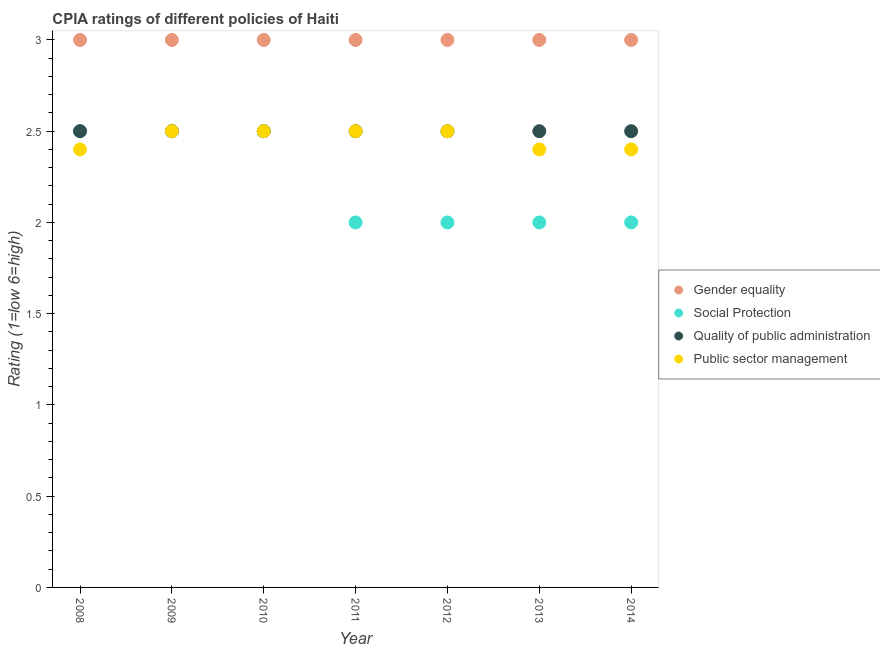What is the difference between the cpia rating of social protection in 2012 and the cpia rating of public sector management in 2008?
Your answer should be compact. -0.4. What is the ratio of the cpia rating of public sector management in 2011 to that in 2013?
Ensure brevity in your answer.  1.04. What is the difference between the highest and the second highest cpia rating of public sector management?
Your answer should be very brief. 0. In how many years, is the cpia rating of gender equality greater than the average cpia rating of gender equality taken over all years?
Provide a succinct answer. 0. Is the sum of the cpia rating of public sector management in 2009 and 2014 greater than the maximum cpia rating of social protection across all years?
Offer a very short reply. Yes. Is it the case that in every year, the sum of the cpia rating of quality of public administration and cpia rating of gender equality is greater than the sum of cpia rating of public sector management and cpia rating of social protection?
Your answer should be compact. Yes. Is it the case that in every year, the sum of the cpia rating of gender equality and cpia rating of social protection is greater than the cpia rating of quality of public administration?
Your response must be concise. Yes. Does the cpia rating of social protection monotonically increase over the years?
Give a very brief answer. No. Is the cpia rating of quality of public administration strictly less than the cpia rating of gender equality over the years?
Provide a succinct answer. Yes. How many years are there in the graph?
Your answer should be compact. 7. Does the graph contain any zero values?
Offer a terse response. No. Does the graph contain grids?
Ensure brevity in your answer.  No. How many legend labels are there?
Provide a short and direct response. 4. What is the title of the graph?
Provide a short and direct response. CPIA ratings of different policies of Haiti. What is the label or title of the Y-axis?
Provide a short and direct response. Rating (1=low 6=high). What is the Rating (1=low 6=high) in Gender equality in 2008?
Offer a very short reply. 3. What is the Rating (1=low 6=high) in Social Protection in 2008?
Offer a terse response. 2.5. What is the Rating (1=low 6=high) in Quality of public administration in 2008?
Ensure brevity in your answer.  2.5. What is the Rating (1=low 6=high) in Public sector management in 2008?
Your answer should be very brief. 2.4. What is the Rating (1=low 6=high) of Gender equality in 2009?
Keep it short and to the point. 3. What is the Rating (1=low 6=high) in Quality of public administration in 2009?
Offer a terse response. 2.5. What is the Rating (1=low 6=high) in Public sector management in 2009?
Offer a very short reply. 2.5. What is the Rating (1=low 6=high) in Quality of public administration in 2011?
Your answer should be very brief. 2.5. What is the Rating (1=low 6=high) of Public sector management in 2011?
Provide a succinct answer. 2.5. What is the Rating (1=low 6=high) of Quality of public administration in 2013?
Your answer should be compact. 2.5. What is the Rating (1=low 6=high) of Public sector management in 2014?
Provide a short and direct response. 2.4. Across all years, what is the maximum Rating (1=low 6=high) of Social Protection?
Ensure brevity in your answer.  2.5. Across all years, what is the maximum Rating (1=low 6=high) in Quality of public administration?
Keep it short and to the point. 2.5. Across all years, what is the minimum Rating (1=low 6=high) in Social Protection?
Keep it short and to the point. 2. Across all years, what is the minimum Rating (1=low 6=high) of Public sector management?
Your answer should be very brief. 2.4. What is the total Rating (1=low 6=high) in Gender equality in the graph?
Offer a terse response. 21. What is the total Rating (1=low 6=high) in Social Protection in the graph?
Make the answer very short. 15.5. What is the total Rating (1=low 6=high) in Public sector management in the graph?
Offer a very short reply. 17.2. What is the difference between the Rating (1=low 6=high) of Gender equality in 2008 and that in 2009?
Give a very brief answer. 0. What is the difference between the Rating (1=low 6=high) of Gender equality in 2008 and that in 2010?
Offer a terse response. 0. What is the difference between the Rating (1=low 6=high) of Public sector management in 2008 and that in 2010?
Give a very brief answer. -0.1. What is the difference between the Rating (1=low 6=high) of Quality of public administration in 2008 and that in 2011?
Offer a terse response. 0. What is the difference between the Rating (1=low 6=high) of Gender equality in 2008 and that in 2012?
Provide a short and direct response. 0. What is the difference between the Rating (1=low 6=high) in Social Protection in 2008 and that in 2012?
Provide a succinct answer. 0.5. What is the difference between the Rating (1=low 6=high) of Social Protection in 2008 and that in 2013?
Offer a very short reply. 0.5. What is the difference between the Rating (1=low 6=high) of Quality of public administration in 2008 and that in 2013?
Your response must be concise. 0. What is the difference between the Rating (1=low 6=high) of Public sector management in 2008 and that in 2013?
Your answer should be compact. 0. What is the difference between the Rating (1=low 6=high) of Quality of public administration in 2008 and that in 2014?
Offer a very short reply. 0. What is the difference between the Rating (1=low 6=high) of Social Protection in 2009 and that in 2010?
Your answer should be compact. 0. What is the difference between the Rating (1=low 6=high) in Quality of public administration in 2009 and that in 2010?
Your answer should be compact. 0. What is the difference between the Rating (1=low 6=high) of Gender equality in 2009 and that in 2012?
Your answer should be compact. 0. What is the difference between the Rating (1=low 6=high) in Social Protection in 2009 and that in 2012?
Your answer should be compact. 0.5. What is the difference between the Rating (1=low 6=high) in Quality of public administration in 2009 and that in 2012?
Give a very brief answer. 0. What is the difference between the Rating (1=low 6=high) of Public sector management in 2009 and that in 2012?
Your response must be concise. 0. What is the difference between the Rating (1=low 6=high) of Gender equality in 2009 and that in 2013?
Provide a succinct answer. 0. What is the difference between the Rating (1=low 6=high) in Social Protection in 2009 and that in 2013?
Keep it short and to the point. 0.5. What is the difference between the Rating (1=low 6=high) of Public sector management in 2009 and that in 2013?
Make the answer very short. 0.1. What is the difference between the Rating (1=low 6=high) in Gender equality in 2009 and that in 2014?
Make the answer very short. 0. What is the difference between the Rating (1=low 6=high) in Social Protection in 2009 and that in 2014?
Offer a terse response. 0.5. What is the difference between the Rating (1=low 6=high) in Quality of public administration in 2009 and that in 2014?
Provide a short and direct response. 0. What is the difference between the Rating (1=low 6=high) of Public sector management in 2009 and that in 2014?
Your answer should be very brief. 0.1. What is the difference between the Rating (1=low 6=high) of Social Protection in 2010 and that in 2011?
Ensure brevity in your answer.  0.5. What is the difference between the Rating (1=low 6=high) of Quality of public administration in 2010 and that in 2011?
Your response must be concise. 0. What is the difference between the Rating (1=low 6=high) of Quality of public administration in 2010 and that in 2012?
Make the answer very short. 0. What is the difference between the Rating (1=low 6=high) in Public sector management in 2010 and that in 2012?
Give a very brief answer. 0. What is the difference between the Rating (1=low 6=high) in Gender equality in 2010 and that in 2013?
Provide a succinct answer. 0. What is the difference between the Rating (1=low 6=high) of Social Protection in 2010 and that in 2013?
Offer a very short reply. 0.5. What is the difference between the Rating (1=low 6=high) in Public sector management in 2010 and that in 2014?
Offer a terse response. 0.1. What is the difference between the Rating (1=low 6=high) of Social Protection in 2011 and that in 2012?
Provide a succinct answer. 0. What is the difference between the Rating (1=low 6=high) in Quality of public administration in 2011 and that in 2012?
Your answer should be compact. 0. What is the difference between the Rating (1=low 6=high) in Public sector management in 2011 and that in 2012?
Provide a succinct answer. 0. What is the difference between the Rating (1=low 6=high) in Social Protection in 2011 and that in 2013?
Provide a short and direct response. 0. What is the difference between the Rating (1=low 6=high) of Quality of public administration in 2011 and that in 2013?
Provide a short and direct response. 0. What is the difference between the Rating (1=low 6=high) of Public sector management in 2011 and that in 2013?
Make the answer very short. 0.1. What is the difference between the Rating (1=low 6=high) of Gender equality in 2011 and that in 2014?
Ensure brevity in your answer.  0. What is the difference between the Rating (1=low 6=high) in Social Protection in 2011 and that in 2014?
Your answer should be compact. 0. What is the difference between the Rating (1=low 6=high) of Gender equality in 2012 and that in 2013?
Provide a short and direct response. 0. What is the difference between the Rating (1=low 6=high) of Social Protection in 2012 and that in 2013?
Offer a very short reply. 0. What is the difference between the Rating (1=low 6=high) of Quality of public administration in 2012 and that in 2013?
Keep it short and to the point. 0. What is the difference between the Rating (1=low 6=high) in Public sector management in 2012 and that in 2013?
Give a very brief answer. 0.1. What is the difference between the Rating (1=low 6=high) in Gender equality in 2012 and that in 2014?
Provide a short and direct response. 0. What is the difference between the Rating (1=low 6=high) of Public sector management in 2012 and that in 2014?
Offer a very short reply. 0.1. What is the difference between the Rating (1=low 6=high) in Gender equality in 2013 and that in 2014?
Provide a succinct answer. 0. What is the difference between the Rating (1=low 6=high) of Social Protection in 2013 and that in 2014?
Provide a succinct answer. 0. What is the difference between the Rating (1=low 6=high) in Quality of public administration in 2013 and that in 2014?
Ensure brevity in your answer.  0. What is the difference between the Rating (1=low 6=high) of Public sector management in 2013 and that in 2014?
Your answer should be compact. 0. What is the difference between the Rating (1=low 6=high) in Gender equality in 2008 and the Rating (1=low 6=high) in Social Protection in 2009?
Ensure brevity in your answer.  0.5. What is the difference between the Rating (1=low 6=high) of Gender equality in 2008 and the Rating (1=low 6=high) of Quality of public administration in 2009?
Make the answer very short. 0.5. What is the difference between the Rating (1=low 6=high) in Gender equality in 2008 and the Rating (1=low 6=high) in Public sector management in 2009?
Offer a terse response. 0.5. What is the difference between the Rating (1=low 6=high) in Social Protection in 2008 and the Rating (1=low 6=high) in Public sector management in 2009?
Your response must be concise. 0. What is the difference between the Rating (1=low 6=high) in Gender equality in 2008 and the Rating (1=low 6=high) in Social Protection in 2010?
Keep it short and to the point. 0.5. What is the difference between the Rating (1=low 6=high) of Gender equality in 2008 and the Rating (1=low 6=high) of Public sector management in 2010?
Provide a short and direct response. 0.5. What is the difference between the Rating (1=low 6=high) in Social Protection in 2008 and the Rating (1=low 6=high) in Public sector management in 2010?
Your answer should be very brief. 0. What is the difference between the Rating (1=low 6=high) of Quality of public administration in 2008 and the Rating (1=low 6=high) of Public sector management in 2010?
Your answer should be compact. 0. What is the difference between the Rating (1=low 6=high) of Gender equality in 2008 and the Rating (1=low 6=high) of Social Protection in 2011?
Offer a very short reply. 1. What is the difference between the Rating (1=low 6=high) in Gender equality in 2008 and the Rating (1=low 6=high) in Quality of public administration in 2011?
Provide a short and direct response. 0.5. What is the difference between the Rating (1=low 6=high) in Gender equality in 2008 and the Rating (1=low 6=high) in Public sector management in 2011?
Provide a short and direct response. 0.5. What is the difference between the Rating (1=low 6=high) of Social Protection in 2008 and the Rating (1=low 6=high) of Public sector management in 2011?
Give a very brief answer. 0. What is the difference between the Rating (1=low 6=high) in Quality of public administration in 2008 and the Rating (1=low 6=high) in Public sector management in 2011?
Provide a short and direct response. 0. What is the difference between the Rating (1=low 6=high) of Gender equality in 2008 and the Rating (1=low 6=high) of Social Protection in 2012?
Make the answer very short. 1. What is the difference between the Rating (1=low 6=high) of Gender equality in 2008 and the Rating (1=low 6=high) of Quality of public administration in 2012?
Ensure brevity in your answer.  0.5. What is the difference between the Rating (1=low 6=high) of Gender equality in 2008 and the Rating (1=low 6=high) of Social Protection in 2013?
Keep it short and to the point. 1. What is the difference between the Rating (1=low 6=high) in Gender equality in 2008 and the Rating (1=low 6=high) in Quality of public administration in 2013?
Give a very brief answer. 0.5. What is the difference between the Rating (1=low 6=high) of Gender equality in 2008 and the Rating (1=low 6=high) of Public sector management in 2013?
Ensure brevity in your answer.  0.6. What is the difference between the Rating (1=low 6=high) of Quality of public administration in 2008 and the Rating (1=low 6=high) of Public sector management in 2013?
Offer a terse response. 0.1. What is the difference between the Rating (1=low 6=high) in Gender equality in 2008 and the Rating (1=low 6=high) in Social Protection in 2014?
Make the answer very short. 1. What is the difference between the Rating (1=low 6=high) of Gender equality in 2008 and the Rating (1=low 6=high) of Public sector management in 2014?
Ensure brevity in your answer.  0.6. What is the difference between the Rating (1=low 6=high) in Social Protection in 2008 and the Rating (1=low 6=high) in Quality of public administration in 2014?
Your answer should be very brief. 0. What is the difference between the Rating (1=low 6=high) of Social Protection in 2008 and the Rating (1=low 6=high) of Public sector management in 2014?
Your response must be concise. 0.1. What is the difference between the Rating (1=low 6=high) in Quality of public administration in 2008 and the Rating (1=low 6=high) in Public sector management in 2014?
Give a very brief answer. 0.1. What is the difference between the Rating (1=low 6=high) of Gender equality in 2009 and the Rating (1=low 6=high) of Social Protection in 2010?
Ensure brevity in your answer.  0.5. What is the difference between the Rating (1=low 6=high) in Gender equality in 2009 and the Rating (1=low 6=high) in Quality of public administration in 2010?
Offer a very short reply. 0.5. What is the difference between the Rating (1=low 6=high) in Social Protection in 2009 and the Rating (1=low 6=high) in Public sector management in 2010?
Your answer should be compact. 0. What is the difference between the Rating (1=low 6=high) in Gender equality in 2009 and the Rating (1=low 6=high) in Social Protection in 2011?
Your response must be concise. 1. What is the difference between the Rating (1=low 6=high) of Gender equality in 2009 and the Rating (1=low 6=high) of Quality of public administration in 2011?
Provide a succinct answer. 0.5. What is the difference between the Rating (1=low 6=high) in Gender equality in 2009 and the Rating (1=low 6=high) in Public sector management in 2011?
Make the answer very short. 0.5. What is the difference between the Rating (1=low 6=high) in Quality of public administration in 2009 and the Rating (1=low 6=high) in Public sector management in 2011?
Your answer should be compact. 0. What is the difference between the Rating (1=low 6=high) of Gender equality in 2009 and the Rating (1=low 6=high) of Public sector management in 2012?
Your response must be concise. 0.5. What is the difference between the Rating (1=low 6=high) in Social Protection in 2009 and the Rating (1=low 6=high) in Public sector management in 2012?
Your answer should be very brief. 0. What is the difference between the Rating (1=low 6=high) in Gender equality in 2009 and the Rating (1=low 6=high) in Social Protection in 2013?
Make the answer very short. 1. What is the difference between the Rating (1=low 6=high) of Gender equality in 2009 and the Rating (1=low 6=high) of Quality of public administration in 2013?
Your answer should be compact. 0.5. What is the difference between the Rating (1=low 6=high) in Social Protection in 2009 and the Rating (1=low 6=high) in Quality of public administration in 2013?
Keep it short and to the point. 0. What is the difference between the Rating (1=low 6=high) of Quality of public administration in 2009 and the Rating (1=low 6=high) of Public sector management in 2013?
Ensure brevity in your answer.  0.1. What is the difference between the Rating (1=low 6=high) of Gender equality in 2009 and the Rating (1=low 6=high) of Quality of public administration in 2014?
Your response must be concise. 0.5. What is the difference between the Rating (1=low 6=high) in Social Protection in 2009 and the Rating (1=low 6=high) in Quality of public administration in 2014?
Your answer should be very brief. 0. What is the difference between the Rating (1=low 6=high) in Social Protection in 2009 and the Rating (1=low 6=high) in Public sector management in 2014?
Provide a short and direct response. 0.1. What is the difference between the Rating (1=low 6=high) in Quality of public administration in 2009 and the Rating (1=low 6=high) in Public sector management in 2014?
Your answer should be compact. 0.1. What is the difference between the Rating (1=low 6=high) of Social Protection in 2010 and the Rating (1=low 6=high) of Quality of public administration in 2011?
Provide a short and direct response. 0. What is the difference between the Rating (1=low 6=high) in Social Protection in 2010 and the Rating (1=low 6=high) in Public sector management in 2011?
Make the answer very short. 0. What is the difference between the Rating (1=low 6=high) of Gender equality in 2010 and the Rating (1=low 6=high) of Social Protection in 2012?
Keep it short and to the point. 1. What is the difference between the Rating (1=low 6=high) in Social Protection in 2010 and the Rating (1=low 6=high) in Quality of public administration in 2012?
Ensure brevity in your answer.  0. What is the difference between the Rating (1=low 6=high) of Social Protection in 2010 and the Rating (1=low 6=high) of Public sector management in 2012?
Your answer should be very brief. 0. What is the difference between the Rating (1=low 6=high) in Gender equality in 2010 and the Rating (1=low 6=high) in Public sector management in 2013?
Provide a succinct answer. 0.6. What is the difference between the Rating (1=low 6=high) in Quality of public administration in 2010 and the Rating (1=low 6=high) in Public sector management in 2013?
Your response must be concise. 0.1. What is the difference between the Rating (1=low 6=high) of Gender equality in 2010 and the Rating (1=low 6=high) of Public sector management in 2014?
Give a very brief answer. 0.6. What is the difference between the Rating (1=low 6=high) in Social Protection in 2010 and the Rating (1=low 6=high) in Quality of public administration in 2014?
Offer a very short reply. 0. What is the difference between the Rating (1=low 6=high) of Quality of public administration in 2010 and the Rating (1=low 6=high) of Public sector management in 2014?
Your answer should be very brief. 0.1. What is the difference between the Rating (1=low 6=high) of Gender equality in 2011 and the Rating (1=low 6=high) of Social Protection in 2012?
Provide a short and direct response. 1. What is the difference between the Rating (1=low 6=high) of Gender equality in 2011 and the Rating (1=low 6=high) of Public sector management in 2012?
Provide a succinct answer. 0.5. What is the difference between the Rating (1=low 6=high) of Gender equality in 2011 and the Rating (1=low 6=high) of Social Protection in 2013?
Your answer should be compact. 1. What is the difference between the Rating (1=low 6=high) of Gender equality in 2011 and the Rating (1=low 6=high) of Quality of public administration in 2013?
Provide a short and direct response. 0.5. What is the difference between the Rating (1=low 6=high) of Gender equality in 2011 and the Rating (1=low 6=high) of Public sector management in 2013?
Your response must be concise. 0.6. What is the difference between the Rating (1=low 6=high) of Gender equality in 2011 and the Rating (1=low 6=high) of Quality of public administration in 2014?
Provide a short and direct response. 0.5. What is the difference between the Rating (1=low 6=high) of Gender equality in 2011 and the Rating (1=low 6=high) of Public sector management in 2014?
Your response must be concise. 0.6. What is the difference between the Rating (1=low 6=high) of Gender equality in 2012 and the Rating (1=low 6=high) of Quality of public administration in 2013?
Your answer should be very brief. 0.5. What is the difference between the Rating (1=low 6=high) in Social Protection in 2012 and the Rating (1=low 6=high) in Quality of public administration in 2013?
Your response must be concise. -0.5. What is the difference between the Rating (1=low 6=high) of Social Protection in 2012 and the Rating (1=low 6=high) of Public sector management in 2013?
Your answer should be compact. -0.4. What is the difference between the Rating (1=low 6=high) of Gender equality in 2012 and the Rating (1=low 6=high) of Quality of public administration in 2014?
Keep it short and to the point. 0.5. What is the difference between the Rating (1=low 6=high) of Quality of public administration in 2012 and the Rating (1=low 6=high) of Public sector management in 2014?
Keep it short and to the point. 0.1. What is the difference between the Rating (1=low 6=high) of Social Protection in 2013 and the Rating (1=low 6=high) of Public sector management in 2014?
Your response must be concise. -0.4. What is the average Rating (1=low 6=high) in Social Protection per year?
Give a very brief answer. 2.21. What is the average Rating (1=low 6=high) of Public sector management per year?
Keep it short and to the point. 2.46. In the year 2008, what is the difference between the Rating (1=low 6=high) in Gender equality and Rating (1=low 6=high) in Social Protection?
Provide a succinct answer. 0.5. In the year 2009, what is the difference between the Rating (1=low 6=high) of Gender equality and Rating (1=low 6=high) of Social Protection?
Make the answer very short. 0.5. In the year 2009, what is the difference between the Rating (1=low 6=high) in Social Protection and Rating (1=low 6=high) in Public sector management?
Provide a short and direct response. 0. In the year 2010, what is the difference between the Rating (1=low 6=high) of Quality of public administration and Rating (1=low 6=high) of Public sector management?
Ensure brevity in your answer.  0. In the year 2011, what is the difference between the Rating (1=low 6=high) of Gender equality and Rating (1=low 6=high) of Quality of public administration?
Your answer should be very brief. 0.5. In the year 2011, what is the difference between the Rating (1=low 6=high) of Gender equality and Rating (1=low 6=high) of Public sector management?
Give a very brief answer. 0.5. In the year 2011, what is the difference between the Rating (1=low 6=high) of Quality of public administration and Rating (1=low 6=high) of Public sector management?
Ensure brevity in your answer.  0. In the year 2012, what is the difference between the Rating (1=low 6=high) in Gender equality and Rating (1=low 6=high) in Public sector management?
Ensure brevity in your answer.  0.5. In the year 2012, what is the difference between the Rating (1=low 6=high) of Social Protection and Rating (1=low 6=high) of Quality of public administration?
Offer a terse response. -0.5. In the year 2013, what is the difference between the Rating (1=low 6=high) in Gender equality and Rating (1=low 6=high) in Quality of public administration?
Give a very brief answer. 0.5. In the year 2013, what is the difference between the Rating (1=low 6=high) in Quality of public administration and Rating (1=low 6=high) in Public sector management?
Keep it short and to the point. 0.1. In the year 2014, what is the difference between the Rating (1=low 6=high) of Quality of public administration and Rating (1=low 6=high) of Public sector management?
Make the answer very short. 0.1. What is the ratio of the Rating (1=low 6=high) in Social Protection in 2008 to that in 2009?
Make the answer very short. 1. What is the ratio of the Rating (1=low 6=high) of Gender equality in 2008 to that in 2010?
Ensure brevity in your answer.  1. What is the ratio of the Rating (1=low 6=high) of Quality of public administration in 2008 to that in 2010?
Ensure brevity in your answer.  1. What is the ratio of the Rating (1=low 6=high) of Public sector management in 2008 to that in 2010?
Your response must be concise. 0.96. What is the ratio of the Rating (1=low 6=high) in Gender equality in 2008 to that in 2011?
Provide a succinct answer. 1. What is the ratio of the Rating (1=low 6=high) of Social Protection in 2008 to that in 2011?
Your answer should be compact. 1.25. What is the ratio of the Rating (1=low 6=high) of Public sector management in 2008 to that in 2011?
Provide a short and direct response. 0.96. What is the ratio of the Rating (1=low 6=high) in Social Protection in 2008 to that in 2012?
Your answer should be compact. 1.25. What is the ratio of the Rating (1=low 6=high) of Quality of public administration in 2008 to that in 2012?
Ensure brevity in your answer.  1. What is the ratio of the Rating (1=low 6=high) in Public sector management in 2008 to that in 2012?
Your answer should be very brief. 0.96. What is the ratio of the Rating (1=low 6=high) in Social Protection in 2008 to that in 2013?
Offer a terse response. 1.25. What is the ratio of the Rating (1=low 6=high) in Public sector management in 2008 to that in 2013?
Your answer should be compact. 1. What is the ratio of the Rating (1=low 6=high) of Gender equality in 2009 to that in 2010?
Offer a terse response. 1. What is the ratio of the Rating (1=low 6=high) of Social Protection in 2009 to that in 2010?
Make the answer very short. 1. What is the ratio of the Rating (1=low 6=high) in Social Protection in 2009 to that in 2011?
Ensure brevity in your answer.  1.25. What is the ratio of the Rating (1=low 6=high) in Public sector management in 2009 to that in 2011?
Give a very brief answer. 1. What is the ratio of the Rating (1=low 6=high) of Gender equality in 2009 to that in 2013?
Your response must be concise. 1. What is the ratio of the Rating (1=low 6=high) of Public sector management in 2009 to that in 2013?
Ensure brevity in your answer.  1.04. What is the ratio of the Rating (1=low 6=high) of Gender equality in 2009 to that in 2014?
Ensure brevity in your answer.  1. What is the ratio of the Rating (1=low 6=high) of Social Protection in 2009 to that in 2014?
Provide a short and direct response. 1.25. What is the ratio of the Rating (1=low 6=high) in Public sector management in 2009 to that in 2014?
Keep it short and to the point. 1.04. What is the ratio of the Rating (1=low 6=high) of Gender equality in 2010 to that in 2011?
Offer a very short reply. 1. What is the ratio of the Rating (1=low 6=high) in Quality of public administration in 2010 to that in 2011?
Your answer should be very brief. 1. What is the ratio of the Rating (1=low 6=high) in Public sector management in 2010 to that in 2011?
Your answer should be compact. 1. What is the ratio of the Rating (1=low 6=high) in Social Protection in 2010 to that in 2012?
Ensure brevity in your answer.  1.25. What is the ratio of the Rating (1=low 6=high) of Quality of public administration in 2010 to that in 2012?
Offer a terse response. 1. What is the ratio of the Rating (1=low 6=high) of Public sector management in 2010 to that in 2012?
Make the answer very short. 1. What is the ratio of the Rating (1=low 6=high) in Gender equality in 2010 to that in 2013?
Offer a very short reply. 1. What is the ratio of the Rating (1=low 6=high) of Social Protection in 2010 to that in 2013?
Keep it short and to the point. 1.25. What is the ratio of the Rating (1=low 6=high) of Public sector management in 2010 to that in 2013?
Your answer should be very brief. 1.04. What is the ratio of the Rating (1=low 6=high) of Social Protection in 2010 to that in 2014?
Provide a short and direct response. 1.25. What is the ratio of the Rating (1=low 6=high) of Quality of public administration in 2010 to that in 2014?
Give a very brief answer. 1. What is the ratio of the Rating (1=low 6=high) of Public sector management in 2010 to that in 2014?
Ensure brevity in your answer.  1.04. What is the ratio of the Rating (1=low 6=high) in Gender equality in 2011 to that in 2012?
Give a very brief answer. 1. What is the ratio of the Rating (1=low 6=high) in Quality of public administration in 2011 to that in 2012?
Make the answer very short. 1. What is the ratio of the Rating (1=low 6=high) of Public sector management in 2011 to that in 2012?
Offer a very short reply. 1. What is the ratio of the Rating (1=low 6=high) in Gender equality in 2011 to that in 2013?
Ensure brevity in your answer.  1. What is the ratio of the Rating (1=low 6=high) of Social Protection in 2011 to that in 2013?
Your response must be concise. 1. What is the ratio of the Rating (1=low 6=high) in Public sector management in 2011 to that in 2013?
Make the answer very short. 1.04. What is the ratio of the Rating (1=low 6=high) in Gender equality in 2011 to that in 2014?
Your response must be concise. 1. What is the ratio of the Rating (1=low 6=high) of Public sector management in 2011 to that in 2014?
Your answer should be very brief. 1.04. What is the ratio of the Rating (1=low 6=high) of Public sector management in 2012 to that in 2013?
Keep it short and to the point. 1.04. What is the ratio of the Rating (1=low 6=high) of Quality of public administration in 2012 to that in 2014?
Give a very brief answer. 1. What is the ratio of the Rating (1=low 6=high) in Public sector management in 2012 to that in 2014?
Offer a very short reply. 1.04. What is the ratio of the Rating (1=low 6=high) in Gender equality in 2013 to that in 2014?
Give a very brief answer. 1. What is the ratio of the Rating (1=low 6=high) of Social Protection in 2013 to that in 2014?
Your response must be concise. 1. What is the ratio of the Rating (1=low 6=high) of Public sector management in 2013 to that in 2014?
Provide a succinct answer. 1. What is the difference between the highest and the second highest Rating (1=low 6=high) of Quality of public administration?
Make the answer very short. 0. What is the difference between the highest and the lowest Rating (1=low 6=high) in Gender equality?
Give a very brief answer. 0. What is the difference between the highest and the lowest Rating (1=low 6=high) in Social Protection?
Offer a very short reply. 0.5. What is the difference between the highest and the lowest Rating (1=low 6=high) of Quality of public administration?
Your response must be concise. 0. 